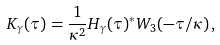<formula> <loc_0><loc_0><loc_500><loc_500>K _ { \gamma } ( \tau ) = \frac { 1 } { \kappa ^ { 2 } } H _ { \gamma } ( \tau ) ^ { * } W _ { 3 } ( - \tau / \kappa ) \, ,</formula> 